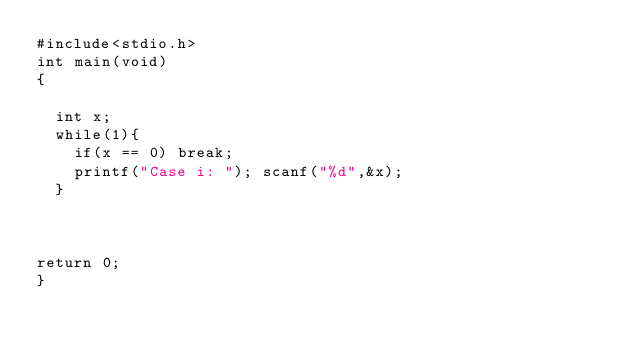<code> <loc_0><loc_0><loc_500><loc_500><_C_>#include<stdio.h>
int main(void)
{

  int x;
  while(1){
    if(x == 0) break;
    printf("Case i: "); scanf("%d",&x);
  }

 

return 0;
}</code> 